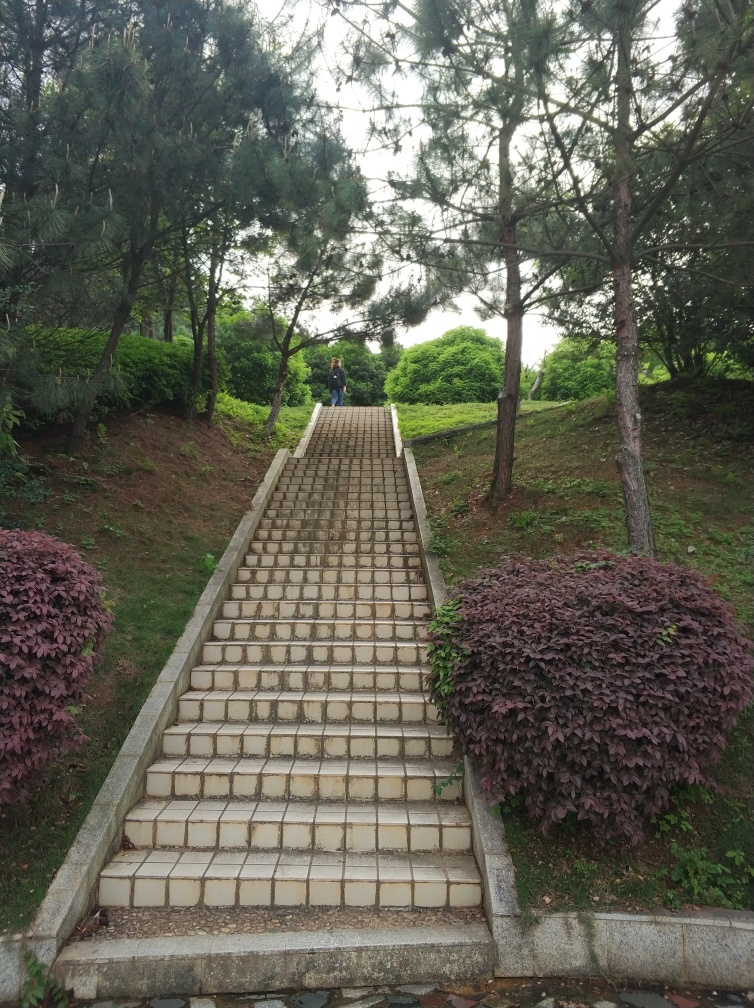Are the texture and details of the stairs rich and clear?
A. No
B. Yes
Answer with the option's letter from the given choices directly.
 B. 